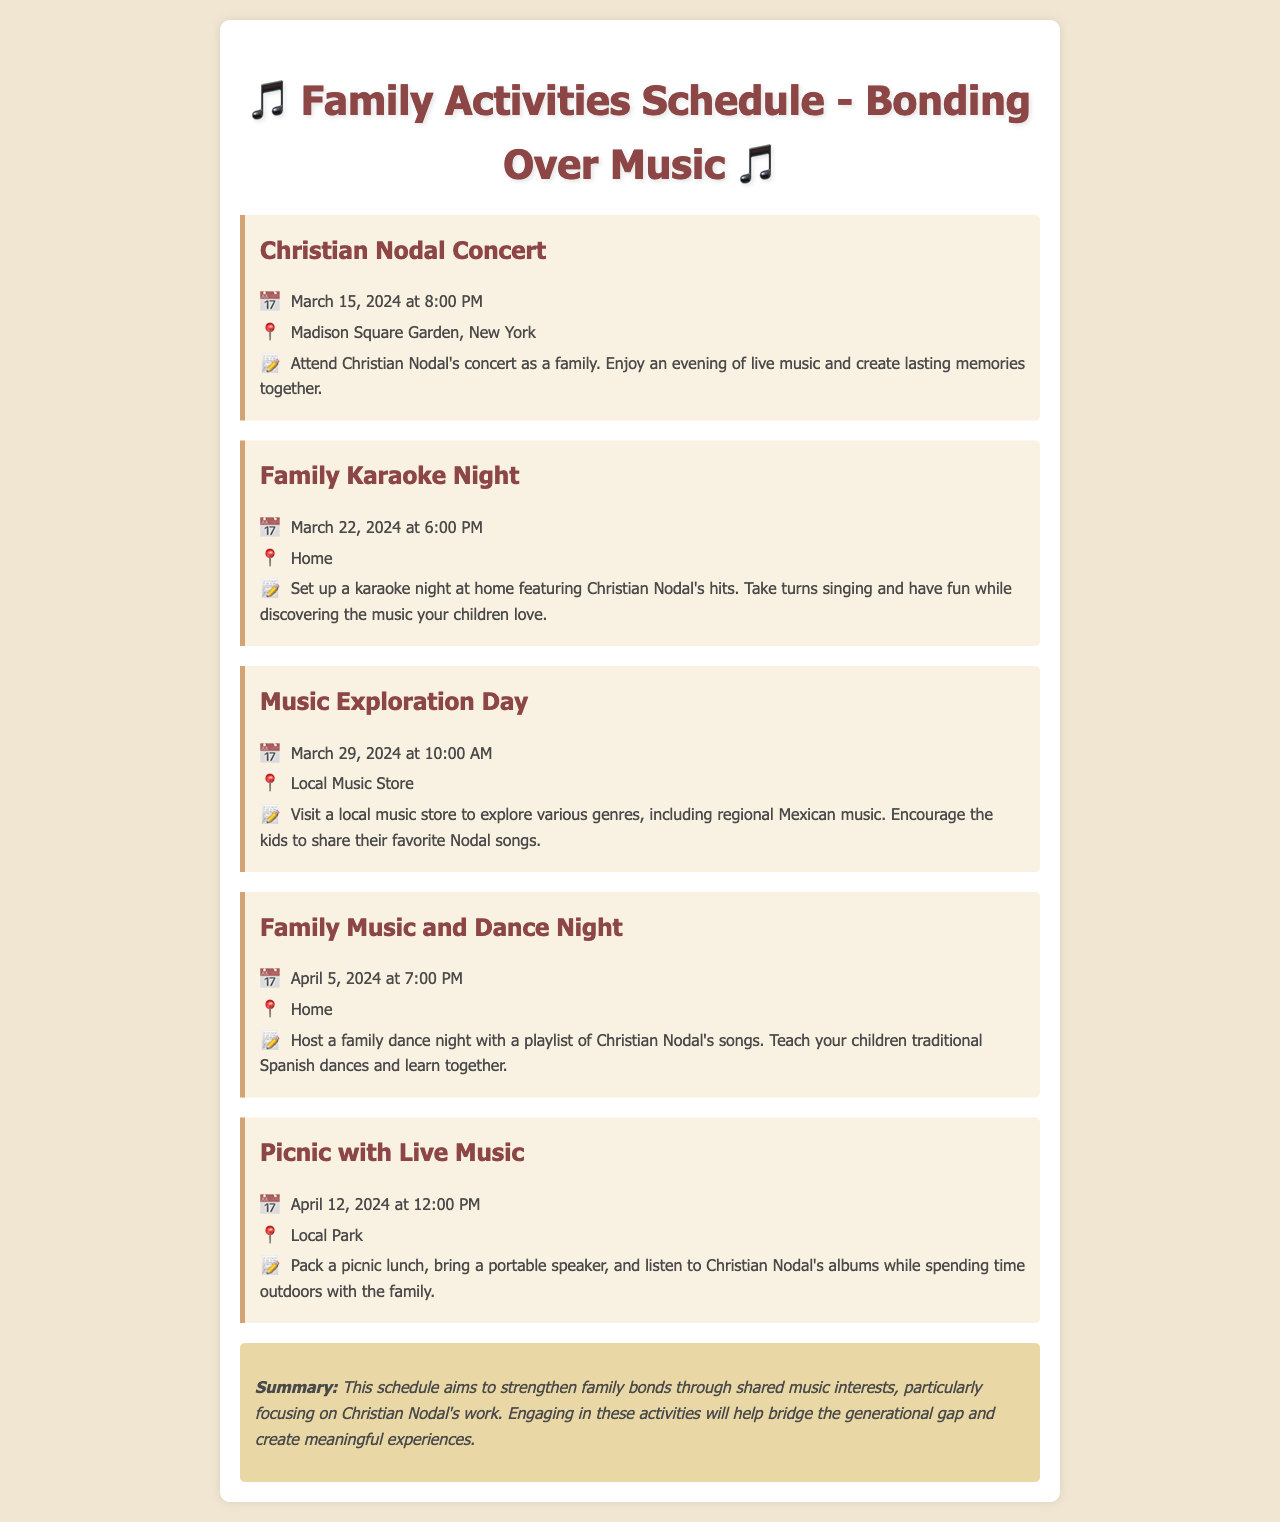What is the date of the Christian Nodal concert? The concert is scheduled for March 15, 2024, as stated in the document.
Answer: March 15, 2024 Where will the Family Karaoke Night take place? The document specifies that the Family Karaoke Night will occur at home.
Answer: Home What type of music will be explored during the Music Exploration Day? The activity focuses on various genres, particularly regional Mexican music as mentioned in the document.
Answer: Regional Mexican music What is the main purpose of the activities listed? The schedule aims to strengthen family bonds through shared music interests, as indicated in the summary.
Answer: Strengthen family bonds What is the time for the Family Music and Dance Night? According to the document, the Family Music and Dance Night is set for 7:00 PM.
Answer: 7:00 PM Which artist's songs will be featured during the Family activities? The document highlights that the activities will feature Christian Nodal's songs.
Answer: Christian Nodal When is the Picnic with Live Music scheduled? The document states that the picnic is scheduled for April 12, 2024.
Answer: April 12, 2024 What is suggested for the Family Karaoke Night? The document suggests setting up a karaoke night featuring Christian Nodal's hits.
Answer: Christian Nodal's hits In which venue will the Christian Nodal concert be held? The document notes that the concert will take place at Madison Square Garden, New York.
Answer: Madison Square Garden, New York 